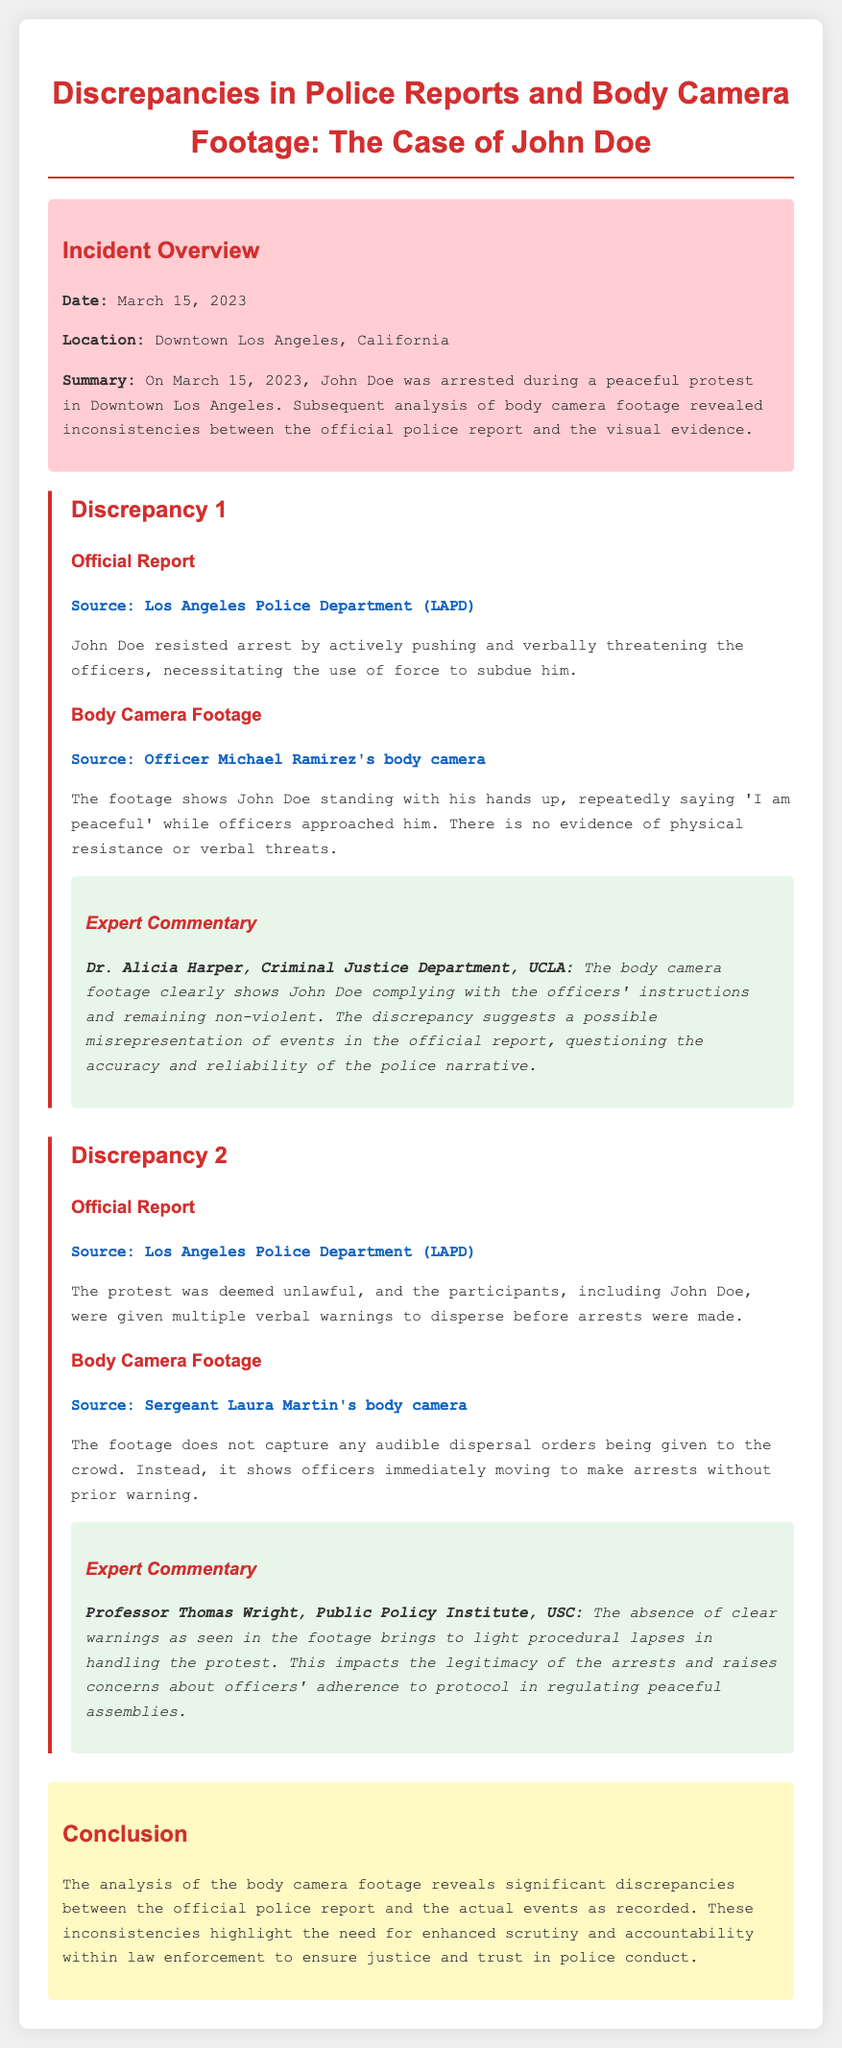What was the date of the incident? The date of the incident is provided in the incident overview section of the document.
Answer: March 15, 2023 Where did the incident take place? The location of the incident is included in the incident overview section.
Answer: Downtown Los Angeles, California Who was arrested during the protest? The name of the individual arrested is mentioned in the summary of the incident.
Answer: John Doe What does the official report claim John Doe did during the arrest? The claim made in the official report regarding John Doe's actions is outlined clearly in the discrepancy section.
Answer: Resisted arrest What does the body camera footage show John Doe saying? The specific words spoken by John Doe in the body camera footage are stated in the discrepancy section of the report.
Answer: "I am peaceful" What procedural aspect does Professor Thomas Wright comment on? The commentary by Professor Thomas Wright focuses on a specific procedural issue related to the protest handling.
Answer: Absence of clear warnings How many discrepancies between the police report and body camera footage are detailed in the document? The document enumerates specific discrepancies related to the incident.
Answer: Two What did Dr. Alicia Harper suggest about the police narrative? The commentary from Dr. Alicia Harper provides insight into the implications of the discrepancies noted.
Answer: Possible misrepresentation What is the impact of the discrepancies on police conduct? The conclusion section emphasizes a broader implication of the documented discrepancies.
Answer: Need for enhanced scrutiny and accountability 